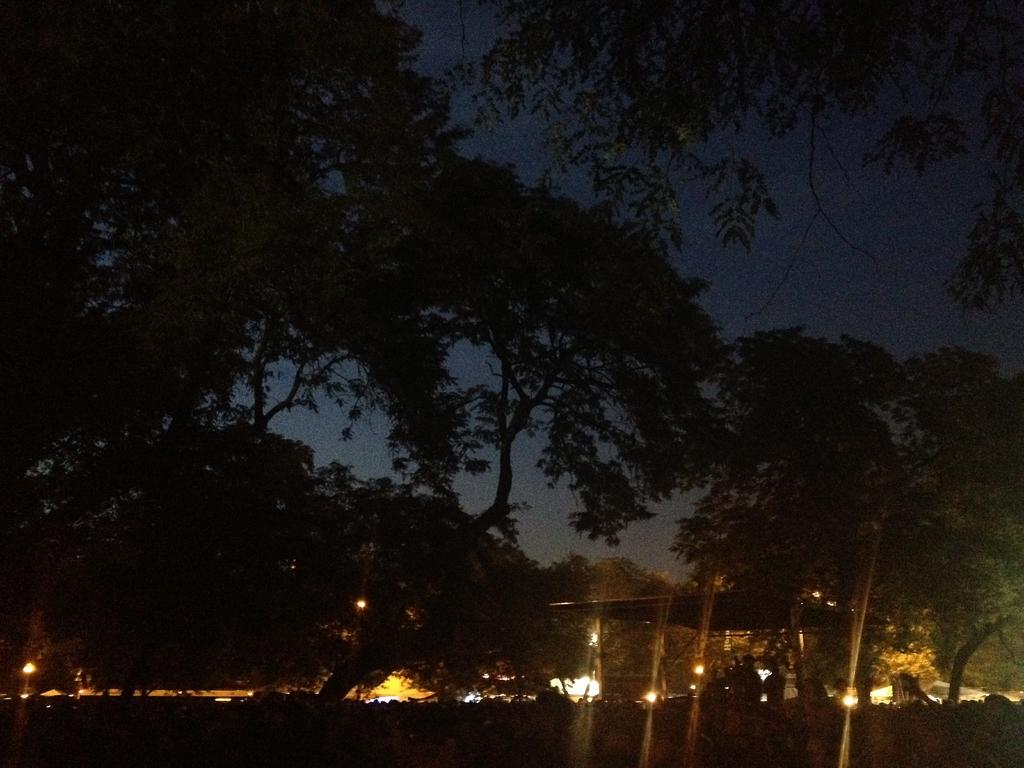What type of natural elements can be seen in the image? There are trees in the image. What type of man-made structures are present in the image? There are houses in the image. What can be seen illuminating the scene in the image? There is light visible in the image. What part of the natural environment is visible in the image? The sky is visible in the image. How would you describe the overall lighting in the image? The image appears to be slightly dark. Can you see a hose being used in the argument between the trees and the houses in the image? There is no argument or hose present in the image. What type of shellfish can be seen near the light source in the image? There are no shellfish present in the image. 